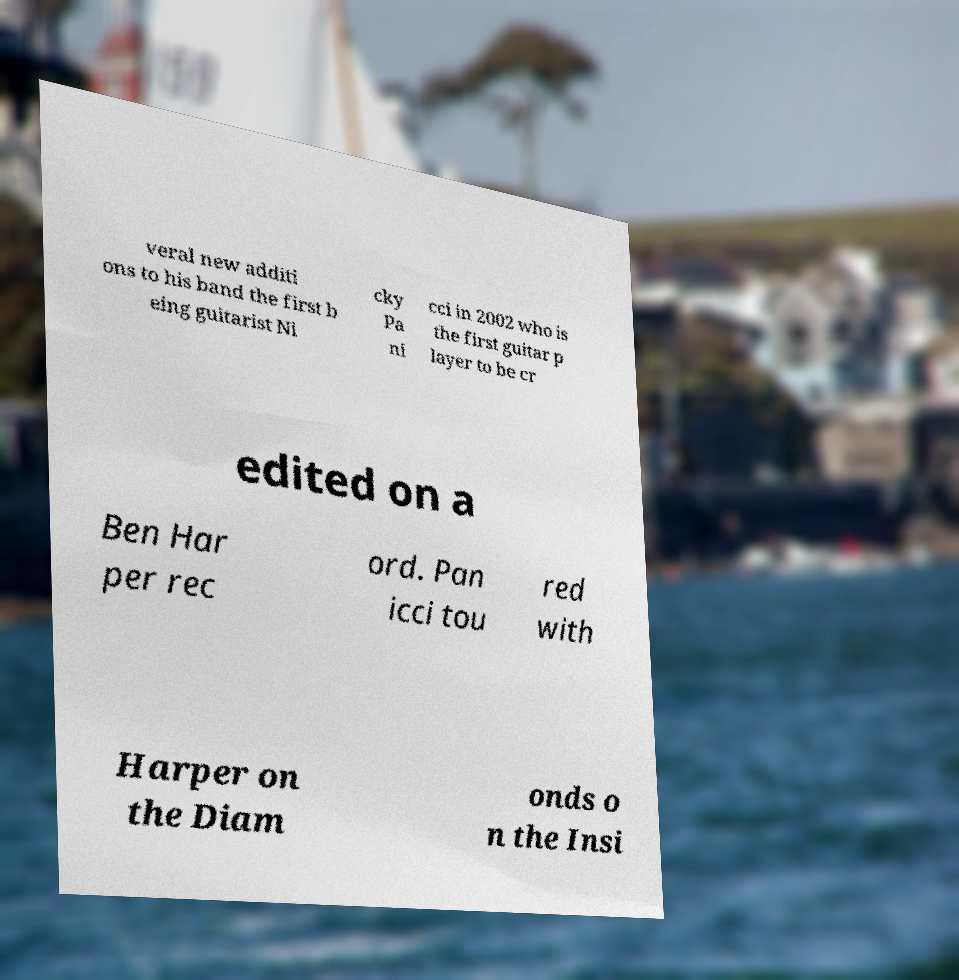For documentation purposes, I need the text within this image transcribed. Could you provide that? veral new additi ons to his band the first b eing guitarist Ni cky Pa ni cci in 2002 who is the first guitar p layer to be cr edited on a Ben Har per rec ord. Pan icci tou red with Harper on the Diam onds o n the Insi 